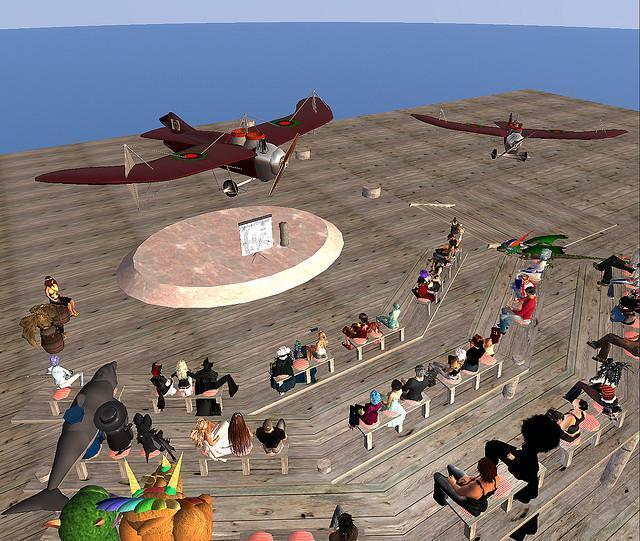How many people are there?
Give a very brief answer. 2. How many airplanes are visible?
Give a very brief answer. 2. 